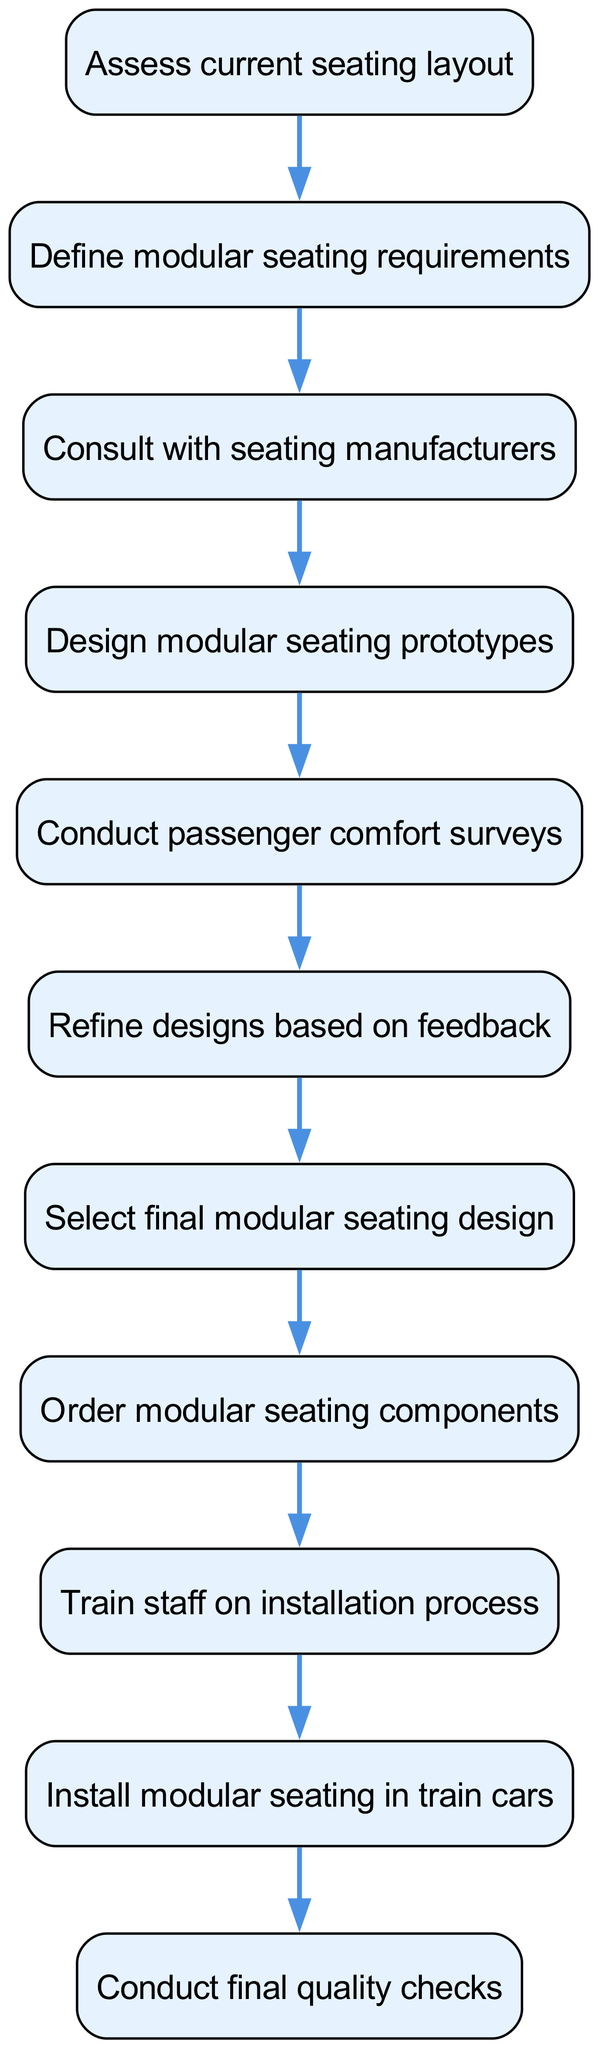What is the first step in the flow? The flow chart begins with the node labeled "Assess current seating layout," which is the first instruction to be followed.
Answer: Assess current seating layout How many total steps are in the flow chart? The flow chart includes 11 nodes (steps) from "Assess current seating layout" to "Conduct final quality checks," making it a total of 11 steps.
Answer: 11 What is the final step before implementation? The last step before the installation of the modular seating is "Train staff on installation process." This indicates that preparation is needed prior to actual installation.
Answer: Train staff on installation process What follows after consulting with seating manufacturers? After "Consult with seating manufacturers," the next step is to "Design modular seating prototypes," representing the logical sequence from consulting experts to actual design.
Answer: Design modular seating prototypes Which step involves gathering feedback from passengers? "Conduct passenger comfort surveys" is the specific step dedicated to gathering feedback from passengers, ensuring their input influences the design process.
Answer: Conduct passenger comfort surveys What is the relationship between the steps "Select final modular seating design" and "Order modular seating components"? The step "Select final modular seating design" directly precedes "Order modular seating components," indicating that the selection of design needs to occur before ordering components.
Answer: Select final modular seating design What step comes after refining designs based on feedback? Following the step "Refine designs based on feedback," the next action is to "Select final modular seating design," which represents the decision-making phase based on the previous refinements.
Answer: Select final modular seating design What major action occurs at step eight? The major action at step eight is to "Order modular seating components," indicating a purchasing phase after the design work has been completed.
Answer: Order modular seating components What is the last action taken in this process? The last action taken in this process is "Conduct final quality checks," which serves as a quality assurance step to ensure everything meets the required standards before completion.
Answer: Conduct final quality checks 